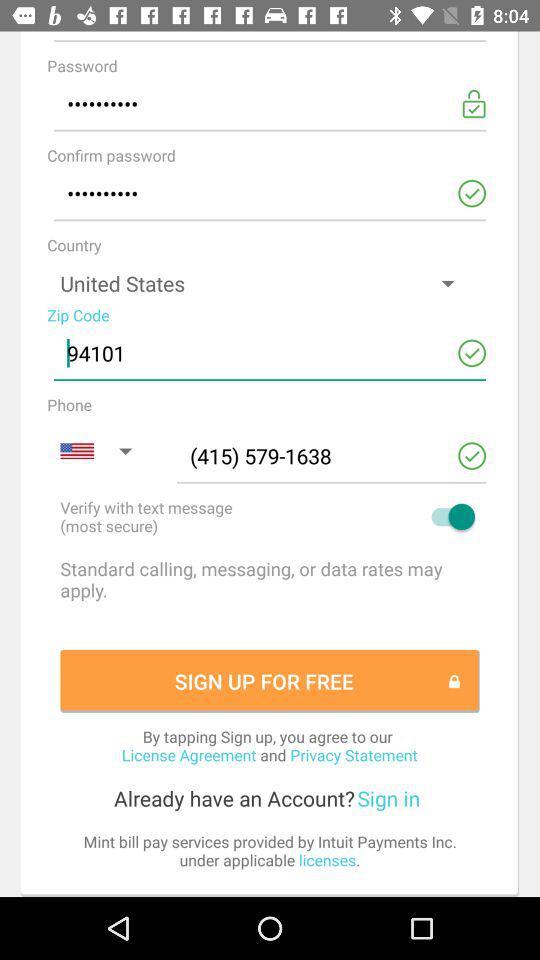What is the Zip code? The Zip code is 94101. 